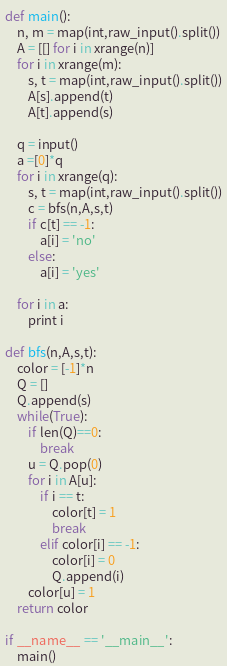<code> <loc_0><loc_0><loc_500><loc_500><_Python_>def main():
    n, m = map(int,raw_input().split())
    A = [[] for i in xrange(n)]
    for i in xrange(m):
        s, t = map(int,raw_input().split())
        A[s].append(t)
        A[t].append(s)

    q = input()
    a =[0]*q
    for i in xrange(q):
        s, t = map(int,raw_input().split())
        c = bfs(n,A,s,t)
        if c[t] == -1:
            a[i] = 'no'
        else:
            a[i] = 'yes'

    for i in a:
        print i
        
def bfs(n,A,s,t):
    color = [-1]*n
    Q = []
    Q.append(s)
    while(True):
        if len(Q)==0:
            break
        u = Q.pop(0)
        for i in A[u]:
            if i == t:
                color[t] = 1
                break
            elif color[i] == -1:
                color[i] = 0
                Q.append(i)
        color[u] = 1
    return color

if __name__ == '__main__':
    main()</code> 